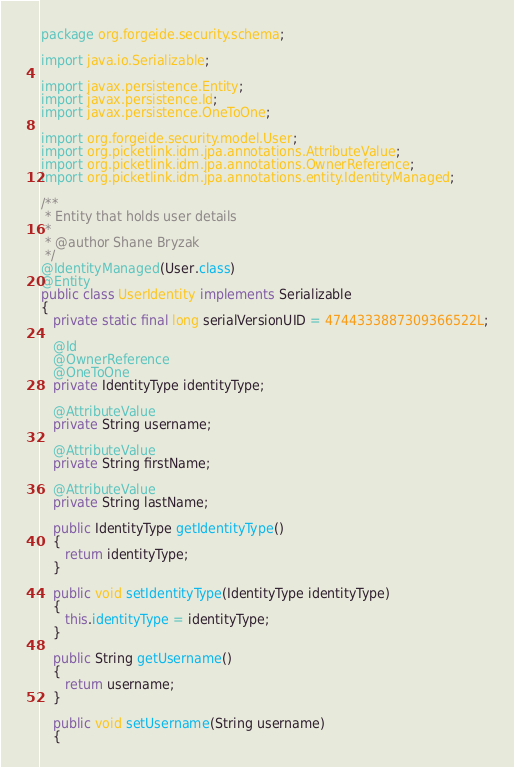Convert code to text. <code><loc_0><loc_0><loc_500><loc_500><_Java_>package org.forgeide.security.schema;

import java.io.Serializable;

import javax.persistence.Entity;
import javax.persistence.Id;
import javax.persistence.OneToOne;

import org.forgeide.security.model.User;
import org.picketlink.idm.jpa.annotations.AttributeValue;
import org.picketlink.idm.jpa.annotations.OwnerReference;
import org.picketlink.idm.jpa.annotations.entity.IdentityManaged;

/**
 * Entity that holds user details
 * 
 * @author Shane Bryzak
 */
@IdentityManaged(User.class)
@Entity
public class UserIdentity implements Serializable
{
   private static final long serialVersionUID = 4744333887309366522L;

   @Id
   @OwnerReference
   @OneToOne
   private IdentityType identityType;

   @AttributeValue
   private String username;

   @AttributeValue
   private String firstName;

   @AttributeValue
   private String lastName;

   public IdentityType getIdentityType()
   {
      return identityType;
   }

   public void setIdentityType(IdentityType identityType)
   {
      this.identityType = identityType;
   }

   public String getUsername()
   {
      return username;
   }

   public void setUsername(String username)
   {</code> 